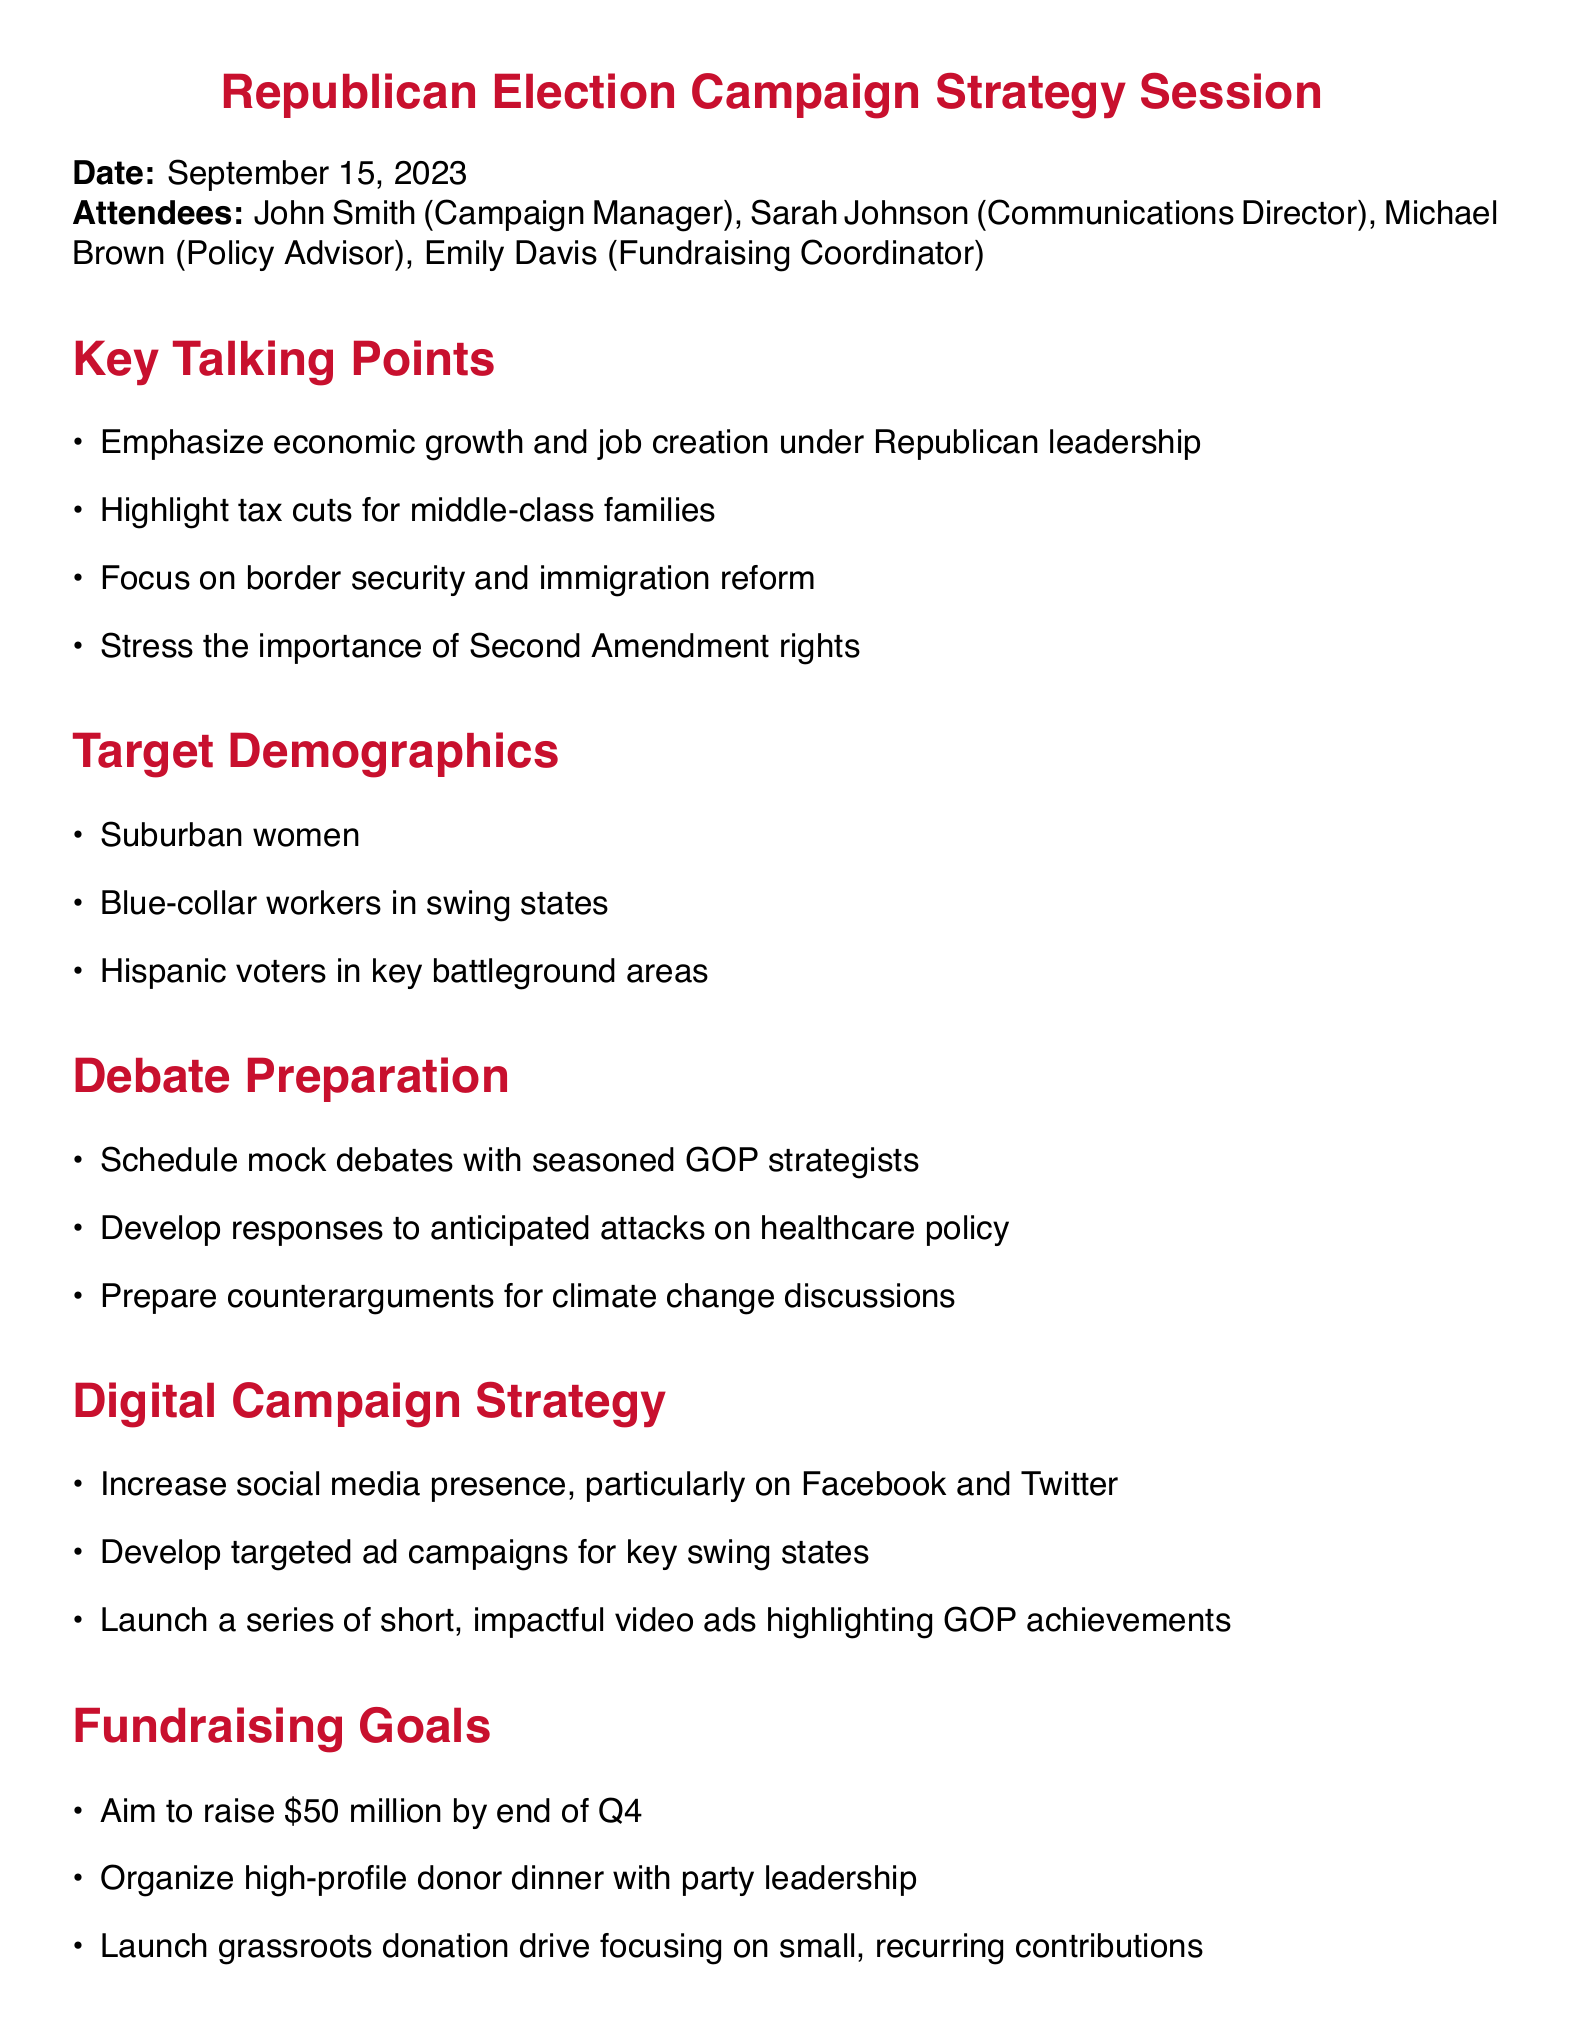What is the title of the meeting? The title of the meeting is listed at the beginning of the document.
Answer: Republican Election Campaign Strategy Session Who chaired the meeting? The document lists the attendees, including the campaign manager, who likely chaired the meeting.
Answer: John Smith What is the date of the meeting? The date of the meeting is specified in the document's header information.
Answer: September 15, 2023 How much money does the campaign aim to raise by the end of Q4? The fundraising goals section outlines the target fundraising amount.
Answer: $50 million Which demographic is targeted under "Target Demographics"? The specific demographics are listed under the Target Demographics section.
Answer: Suburban women What are mock debates mentioned under? The preparation mentioned focuses on strategies for handling debates.
Answer: Debate Preparation When is the press kit due? The document lists action items and their deadlines.
Answer: September 30th What social media platforms are emphasized for digital campaigns? The digital campaign strategy mentions specific platforms.
Answer: Facebook and Twitter What is one key talking point about tax? The key talking points section outlines significant campaign messages about taxes.
Answer: Highlight tax cuts for middle-class families 